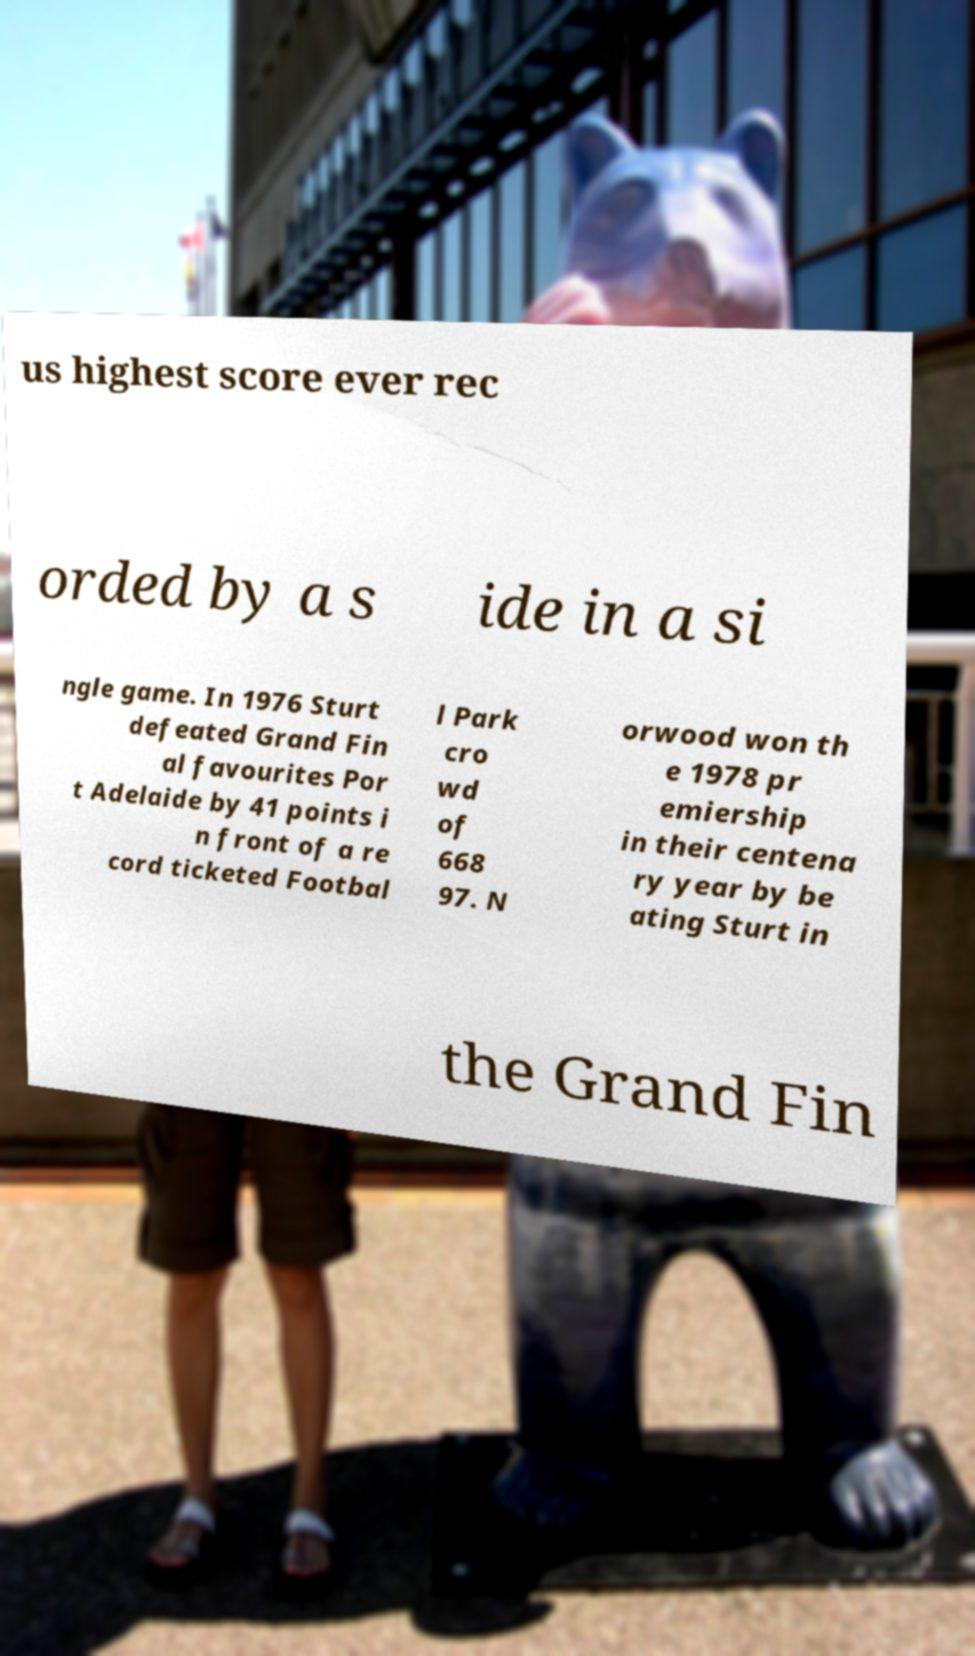Could you assist in decoding the text presented in this image and type it out clearly? us highest score ever rec orded by a s ide in a si ngle game. In 1976 Sturt defeated Grand Fin al favourites Por t Adelaide by 41 points i n front of a re cord ticketed Footbal l Park cro wd of 668 97. N orwood won th e 1978 pr emiership in their centena ry year by be ating Sturt in the Grand Fin 